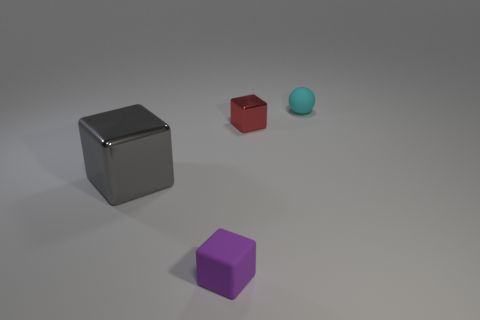How many large objects are purple rubber things or matte spheres?
Ensure brevity in your answer.  0. There is a large metallic thing; what number of big metal objects are behind it?
Provide a short and direct response. 0. Are there any large metallic blocks that have the same color as the large metallic thing?
Your response must be concise. No. There is a purple thing that is the same size as the cyan thing; what is its shape?
Your response must be concise. Cube. What number of purple things are shiny things or big matte things?
Provide a succinct answer. 0. What number of purple matte cubes are the same size as the cyan thing?
Your answer should be very brief. 1. How many things are small gray rubber cubes or small objects on the left side of the tiny sphere?
Make the answer very short. 2. There is a matte object behind the gray metal block; is it the same size as the shiny cube that is left of the purple rubber thing?
Give a very brief answer. No. How many purple matte objects are the same shape as the red metallic object?
Your response must be concise. 1. There is a small purple object that is the same material as the cyan sphere; what shape is it?
Provide a succinct answer. Cube. 